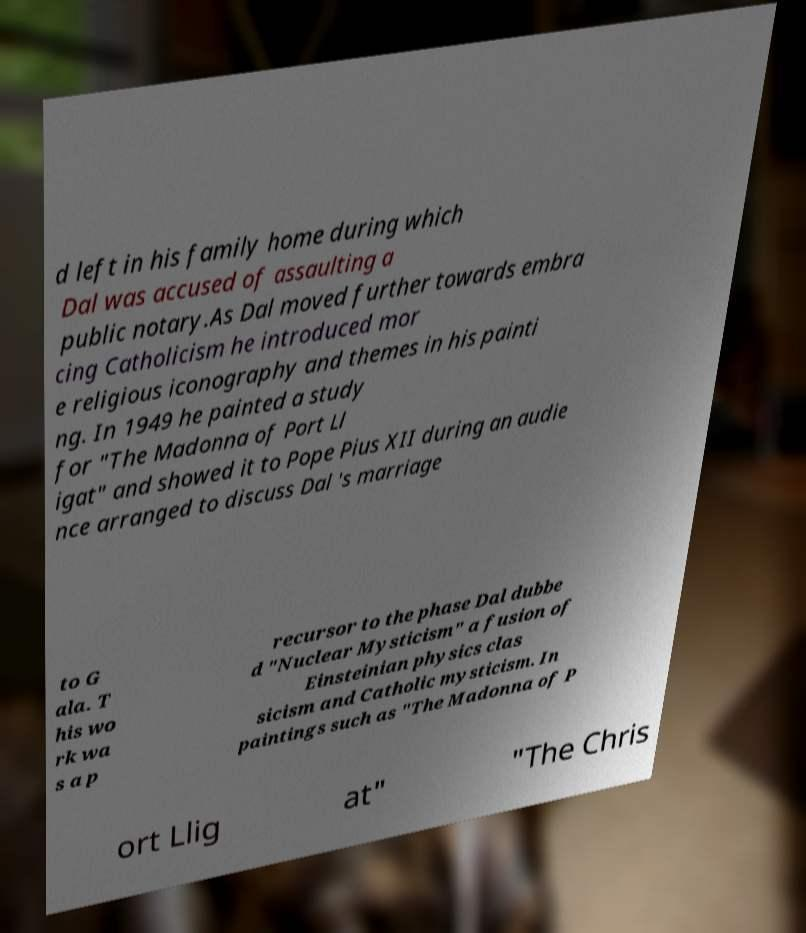Please read and relay the text visible in this image. What does it say? d left in his family home during which Dal was accused of assaulting a public notary.As Dal moved further towards embra cing Catholicism he introduced mor e religious iconography and themes in his painti ng. In 1949 he painted a study for "The Madonna of Port Ll igat" and showed it to Pope Pius XII during an audie nce arranged to discuss Dal 's marriage to G ala. T his wo rk wa s a p recursor to the phase Dal dubbe d "Nuclear Mysticism" a fusion of Einsteinian physics clas sicism and Catholic mysticism. In paintings such as "The Madonna of P ort Llig at" "The Chris 